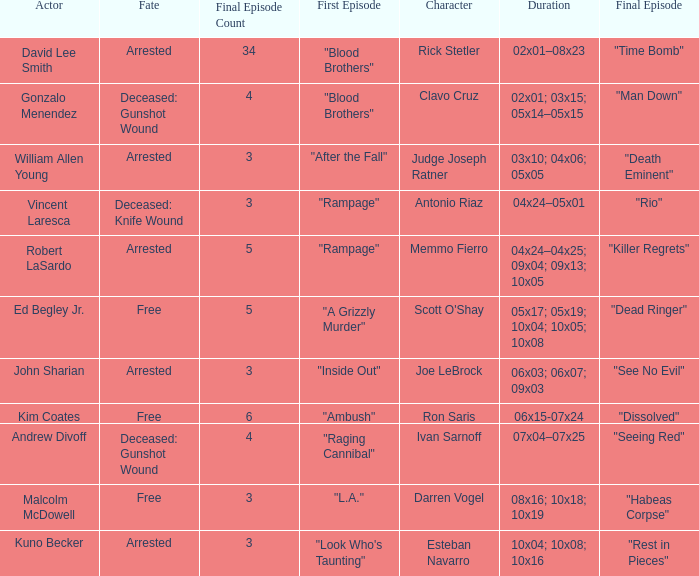What's the complete number of last episodes with the opening episode named "l.a."? 1.0. 